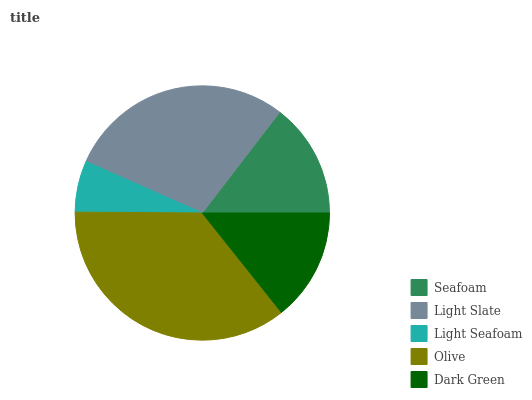Is Light Seafoam the minimum?
Answer yes or no. Yes. Is Olive the maximum?
Answer yes or no. Yes. Is Light Slate the minimum?
Answer yes or no. No. Is Light Slate the maximum?
Answer yes or no. No. Is Light Slate greater than Seafoam?
Answer yes or no. Yes. Is Seafoam less than Light Slate?
Answer yes or no. Yes. Is Seafoam greater than Light Slate?
Answer yes or no. No. Is Light Slate less than Seafoam?
Answer yes or no. No. Is Seafoam the high median?
Answer yes or no. Yes. Is Seafoam the low median?
Answer yes or no. Yes. Is Olive the high median?
Answer yes or no. No. Is Olive the low median?
Answer yes or no. No. 